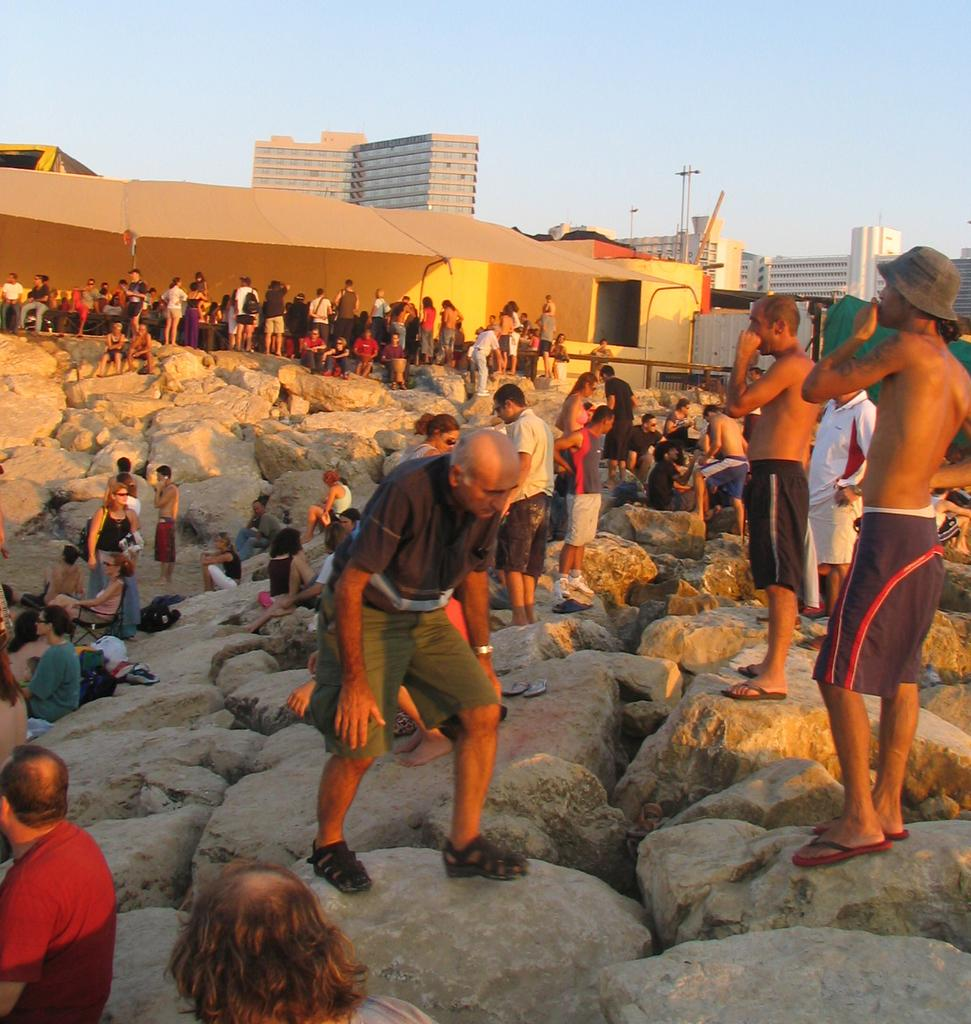How many people are in the image? There is a group of people in the image, but the exact number is not specified. What are the people doing in the image? Some people are standing on stones, while others are sitting on stones. What can be seen in the background of the image? There are buildings, poles, and the sky visible in the background of the image. What type of juice is being served to the people in the image? There is no juice present in the image; it features a group of people standing and sitting on stones with buildings, poles, and the sky visible in the background. 